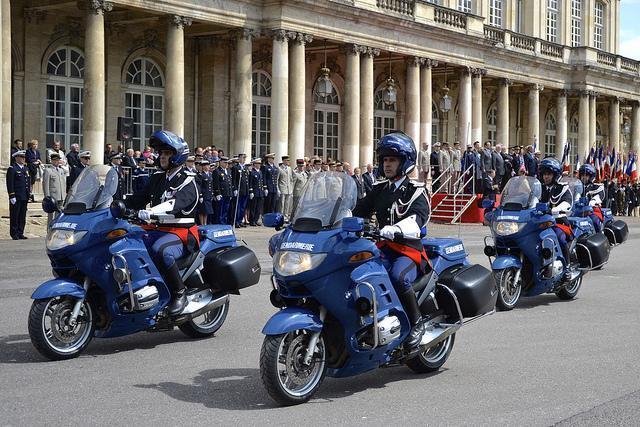How many people can you see?
Give a very brief answer. 3. How many motorcycles are there?
Give a very brief answer. 3. How many cakes are sliced?
Give a very brief answer. 0. 